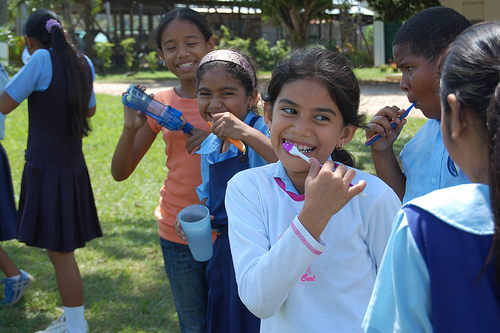Is the fence to the right or to the left of the boy in the scene? The wooden fence is positioned to the left of the boy who appears to be focused on a discussion or an activity off-camera. 